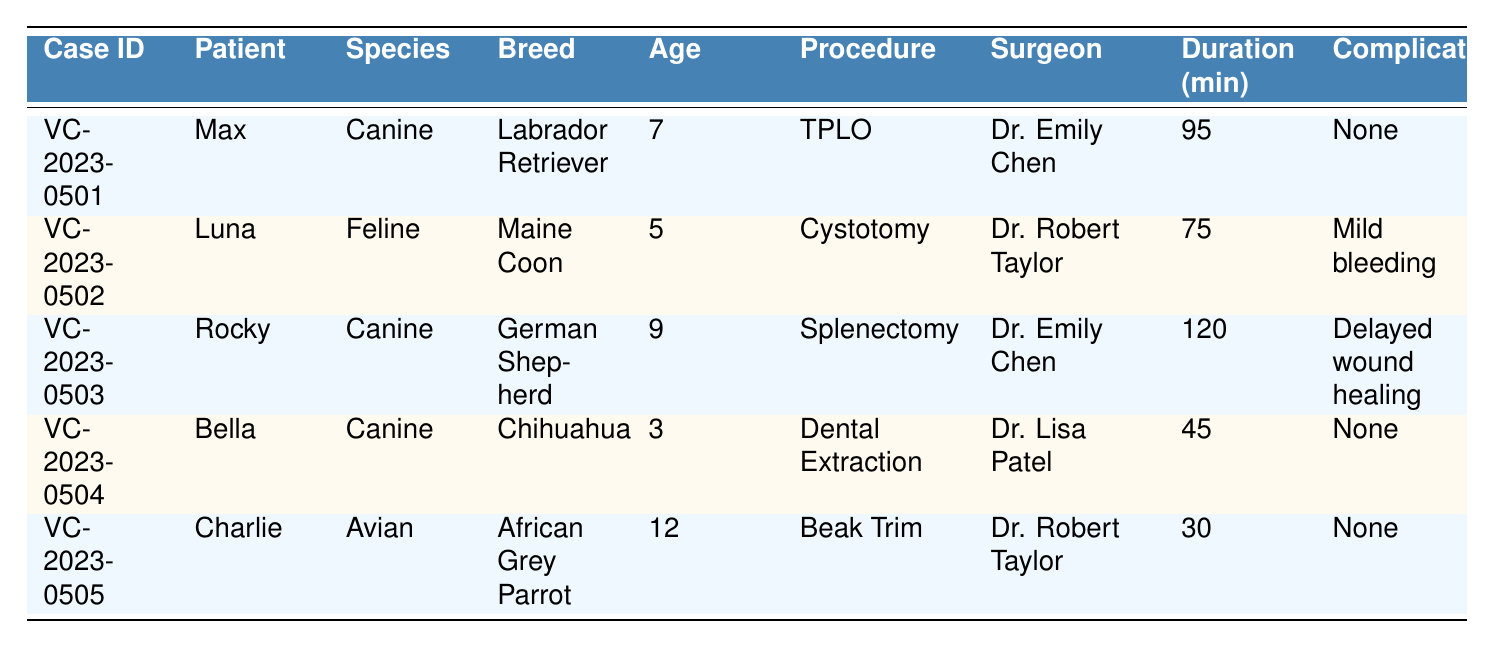What is the procedure type for the patient named Max? The procedure type for Max is listed directly in the table under his entry, which is TPLO.
Answer: TPLO How many days did Bella take to recover after her surgery? The recovery time for Bella is provided in the table, indicating she took 7 days to recover.
Answer: 7 days Which species had the longest surgery duration? By checking the duration values in the table for each species, Rocky (Canine) had the longest surgery duration of 120 minutes.
Answer: Canine Did Charlie's surgery involve any complications? The complications for Charlie's case are noted in the table, and it states "None," meaning there were no complications during or after his surgery.
Answer: No What is the average recovery time for all the surgical cases listed? To compute the average recovery time, we add the recovery times: 14 + 10 + 21 + 7 + 3 = 55 days. There are 5 cases, so 55/5 = 11 days on average.
Answer: 11 days Which surgeon performed the least complex procedure based on the complications reported? To determine this, we look for the procedure with no complications. The only surgeries without complications were performed by Dr. Emily Chen (Max, TPLO) and Dr. Lisa Patel (Bella, Dental Extraction). Between Dr. Emily Chen's and Dr. Lisa Patel's cases, the Dental Extraction is generally considered less complex than TPLO. So, Dr. Lisa Patel performed the least complex procedure.
Answer: Dr. Lisa Patel How many cases listed were performed by Dr. Robert Taylor? By scanning through the table, Dr. Robert Taylor is associated with two cases, Luna's Cystotomy and Charlie's Beak Trim.
Answer: 2 cases Was the post-operative pain score for Rocky higher than that of Max? Comparing the post-operative pain scores, Rocky has a score of 4 while Max has a score of 2. Since 4 is greater than 2, this confirms that Rocky's score was indeed higher.
Answer: Yes What is the difference in recovery time between the longest and shortest recovery cases? The longest recovery time is 21 days (Rocky) and the shortest is 3 days (Charlie). The difference in recovery time is 21 - 3 = 18 days.
Answer: 18 days Which patient had the highest post-operative pain score, and what was it? By reviewing the post-operative pain scores, Rocky had the highest score of 4.
Answer: Rocky, 4 